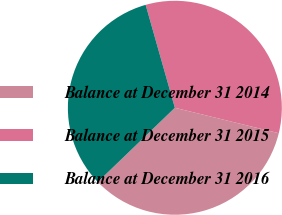Convert chart. <chart><loc_0><loc_0><loc_500><loc_500><pie_chart><fcel>Balance at December 31 2014<fcel>Balance at December 31 2015<fcel>Balance at December 31 2016<nl><fcel>33.98%<fcel>33.22%<fcel>32.8%<nl></chart> 